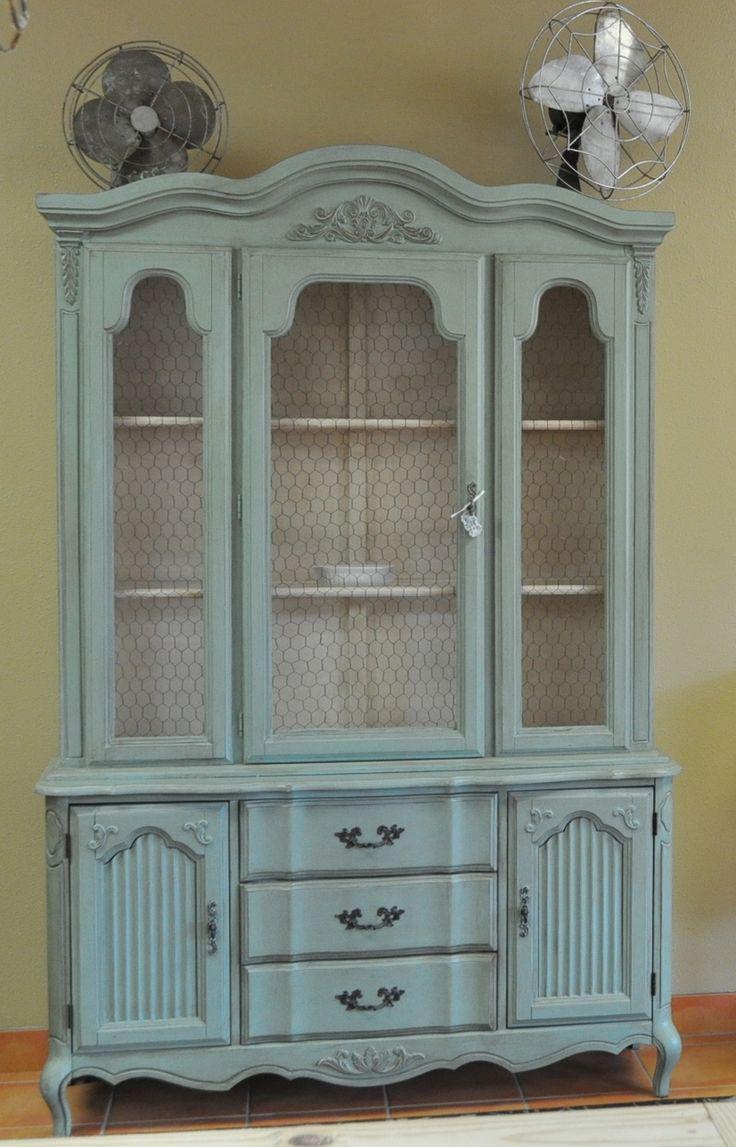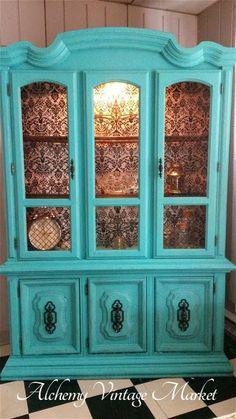The first image is the image on the left, the second image is the image on the right. For the images displayed, is the sentence "The teal cabinet has exactly three lower drawers." factually correct? Answer yes or no. Yes. The first image is the image on the left, the second image is the image on the right. Assess this claim about the two images: "AN image shows a flat-topped cabinet above a three stacked drawer section that is not flat.". Correct or not? Answer yes or no. No. 